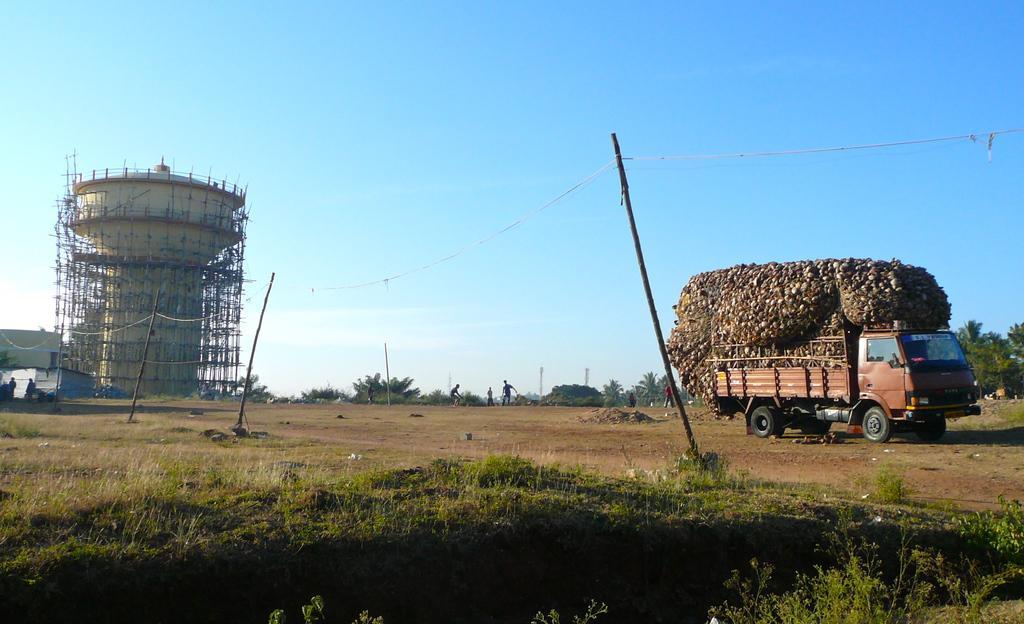Can you describe this image briefly? This is an outside view. On the ground, I can see the grass. On the right side there is a truck carrying a load. On the left side there is a tower and few houses. In the background there are many trees and I can see few people on the ground. At the top of the image I can see the sky. 